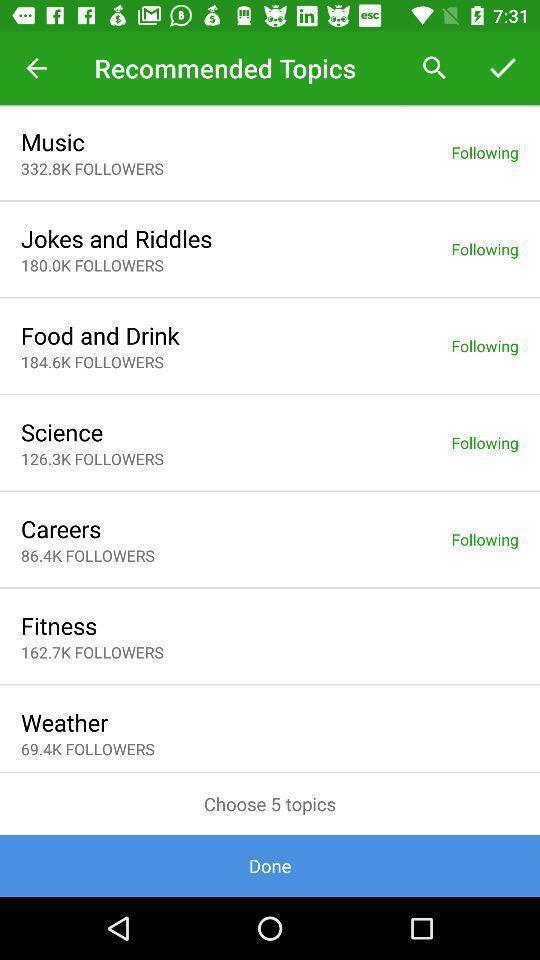Describe this image in words. Various topics displayed. 